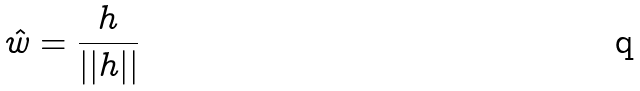Convert formula to latex. <formula><loc_0><loc_0><loc_500><loc_500>\hat { w } = \frac { h } { | | h | | }</formula> 